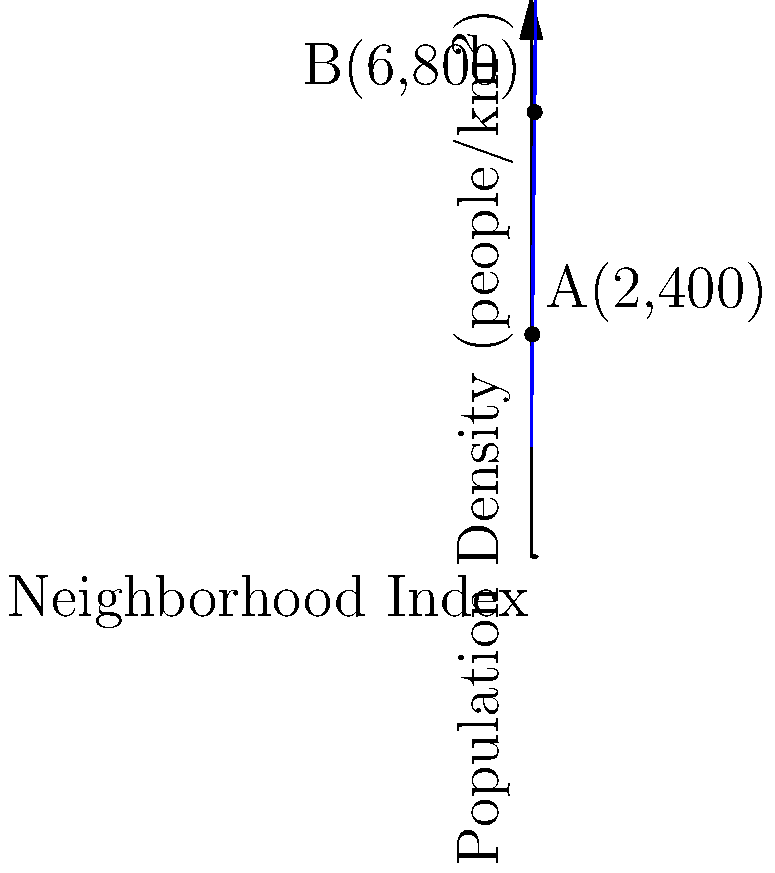As part of your housing policy research, you're analyzing population density trends across different neighborhoods in Winnipeg. The graph shows a linear relationship between neighborhood index and population density. Points A(2,400) and B(6,800) represent two specific neighborhoods. Using this information, determine the expected population density for a neighborhood with an index of 5. To solve this problem, we'll follow these steps:

1) First, we need to find the equation of the line passing through points A and B. The general form of a linear equation is $y = mx + b$, where $m$ is the slope and $b$ is the y-intercept.

2) Calculate the slope $m$:
   $m = \frac{y_2 - y_1}{x_2 - x_1} = \frac{800 - 400}{6 - 2} = \frac{400}{4} = 100$

3) Now that we have the slope, we can use either point to find $b$. Let's use point A(2,400):
   $400 = 100(2) + b$
   $400 = 200 + b$
   $b = 200$

4) Our equation is therefore: $y = 100x + 200$

5) To find the population density for a neighborhood with an index of 5, we simply substitute $x=5$ into our equation:
   $y = 100(5) + 200 = 500 + 200 = 700$

Therefore, the expected population density for a neighborhood with an index of 5 is 700 people/km².
Answer: 700 people/km² 